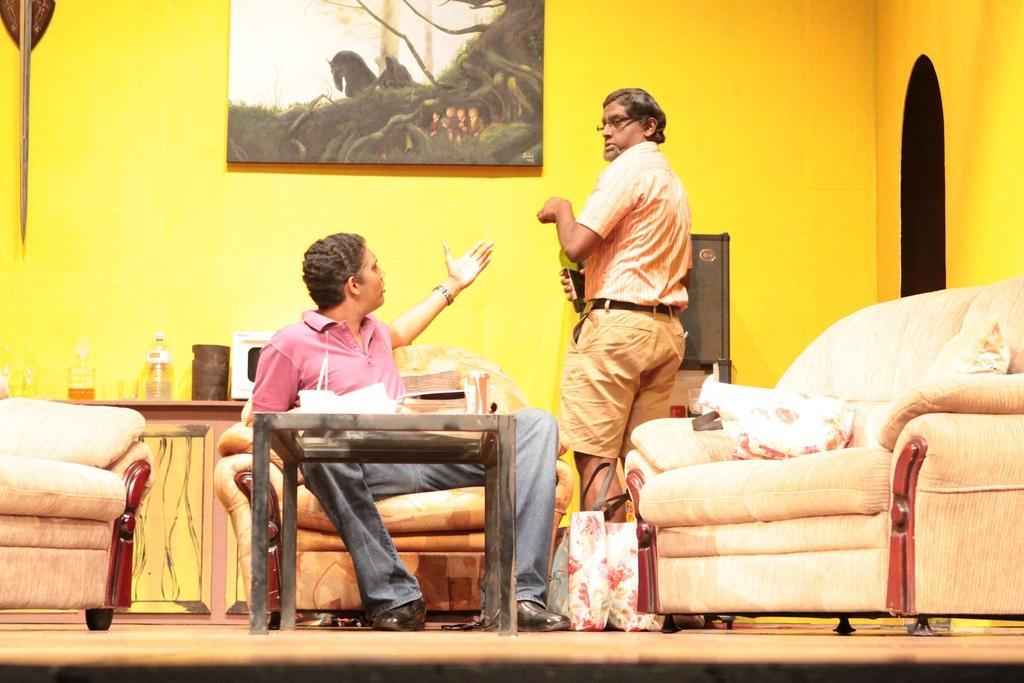Describe this image in one or two sentences. In this image a person is sitting on a chair before a table. Another person is standing by holding a bottle in his hand. Two bags are on the floor. To the right side there is a chair, two cousins in it. Backside there is a table with two bottles are on it. Canvas is fixed to the wall. 